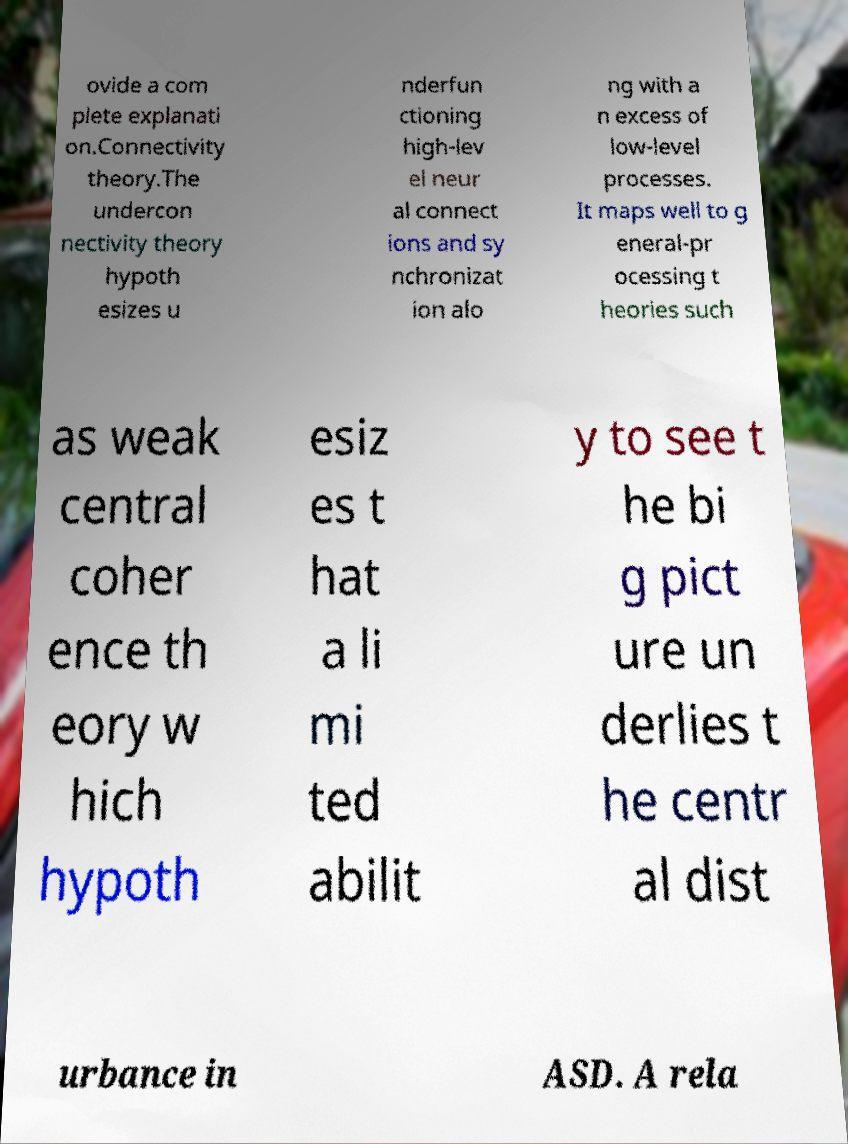Could you extract and type out the text from this image? ovide a com plete explanati on.Connectivity theory.The undercon nectivity theory hypoth esizes u nderfun ctioning high-lev el neur al connect ions and sy nchronizat ion alo ng with a n excess of low-level processes. It maps well to g eneral-pr ocessing t heories such as weak central coher ence th eory w hich hypoth esiz es t hat a li mi ted abilit y to see t he bi g pict ure un derlies t he centr al dist urbance in ASD. A rela 